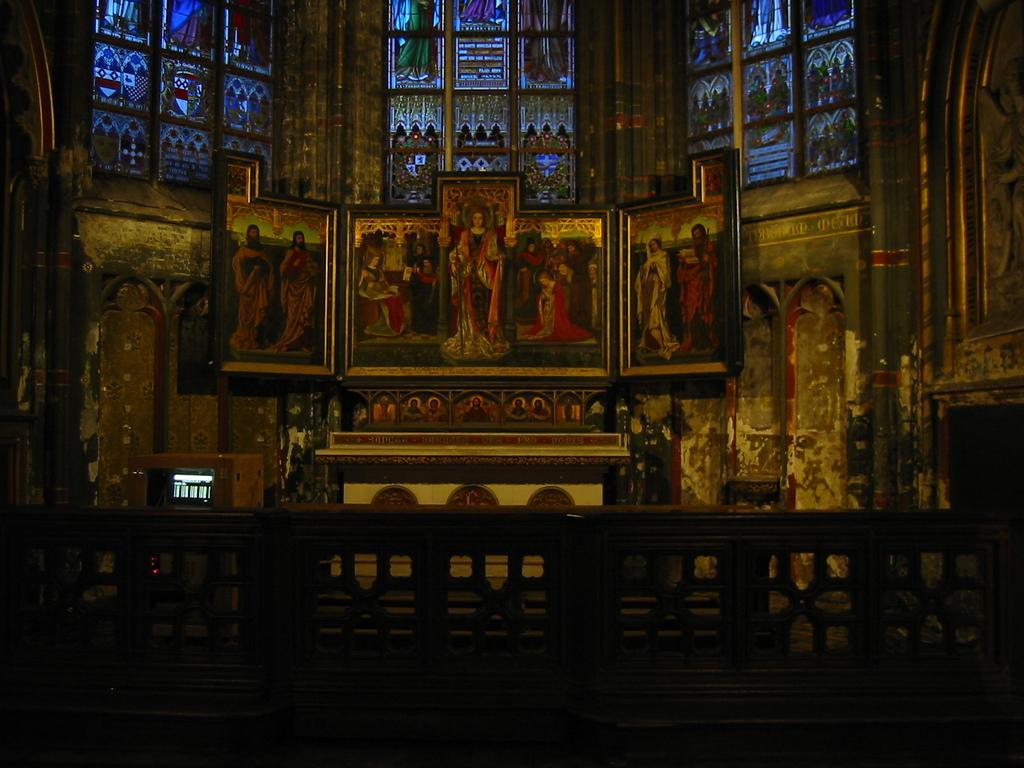In one or two sentences, can you explain what this image depicts? This is an inside view picture of a holy church. We can see painting on the glasses. Bottom portion of the picture is completely dark. On the left side we can see an object. 